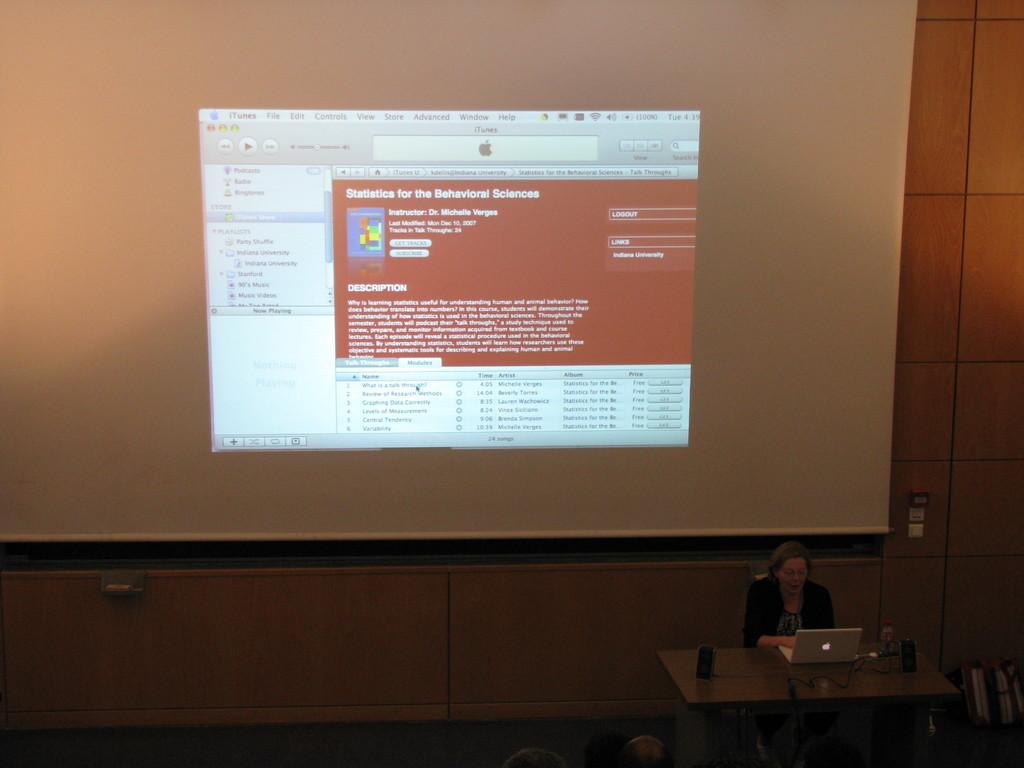<image>
Share a concise interpretation of the image provided. Dr. Michelle Verges is presenting a slide on statistic for the behavioral sciences. 